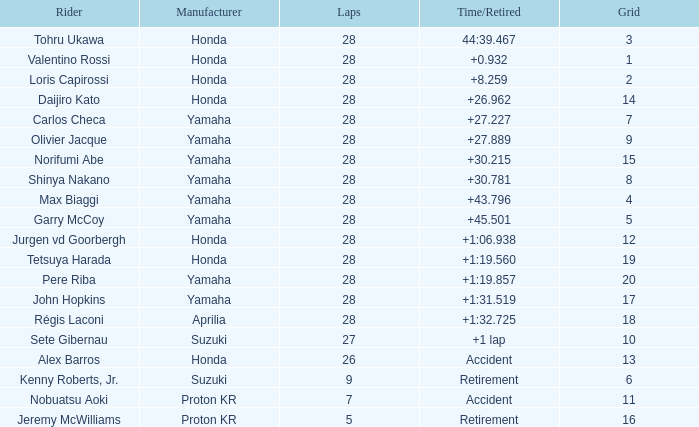How many circuits were in grid 4? 28.0. 